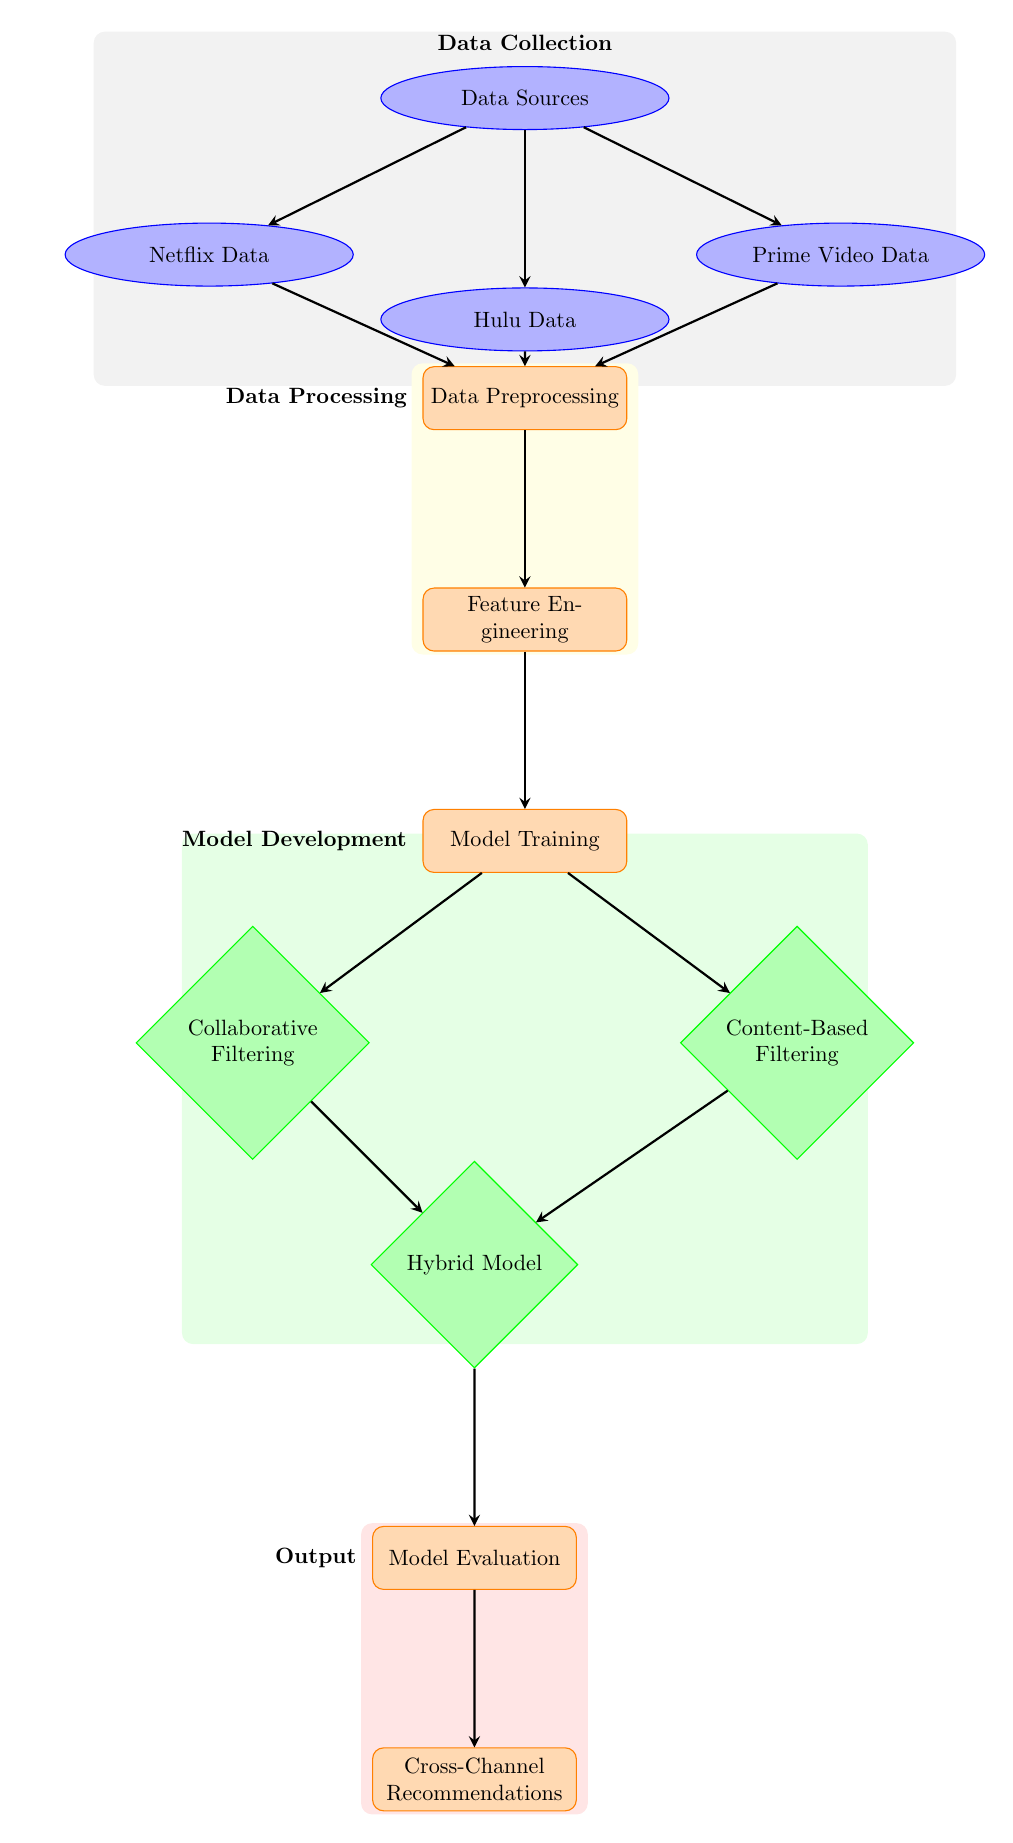What are the three data sources in the diagram? The diagram lists three data sources connected to the "Data Sources" node: Netflix Data, Hulu Data, and Prime Video Data.
Answer: Netflix Data, Hulu Data, Prime Video Data What is the output of the model evaluation step? The output of the "Model Evaluation" process results in "Cross-Channel Recommendations," as depicted by the arrow leading to that node.
Answer: Cross-Channel Recommendations How many models are used in the model training section? There are two models mentioned under the "Model Training" process: Collaborative Filtering and Content-Based Filtering. These are the outputs of the training step.
Answer: Two What is the relationship between data preprocessing and feature engineering? "Data Preprocessing" feeds directly into "Feature Engineering," as indicated by the arrow between these two processes. This means the output of data preprocessing is the input for feature engineering.
Answer: Data Preprocessing feeds into Feature Engineering Which processes occur after model training? After "Model Training," the diagram shows that the subsequent processes include both "Collaborative Filtering" and "Content-Based Filtering," followed by the "Hybrid Model" and "Model Evaluation." Following them, "Cross-Channel Recommendations" is generated.
Answer: Collaborative Filtering, Content-Based Filtering, Hybrid Model, Model Evaluation, Cross-Channel Recommendations What type of filtering is represented by the bottom left model? The model on the bottom left is labeled "Collaborative Filtering," indicating the specific filtering technique used within the overall recommendation system.
Answer: Collaborative Filtering In which section of the diagram does feature engineering occur? "Feature Engineering" is located in the "Data Processing" section as the second process that follows "Data Preprocessing."
Answer: Data Processing How many processes are there in the whole flow of the diagram? The processes in the flow of the diagram are Data Preprocessing, Feature Engineering, Model Training, Model Evaluation, and Cross-Channel Recommendations, totaling five distinct processes.
Answer: Five 